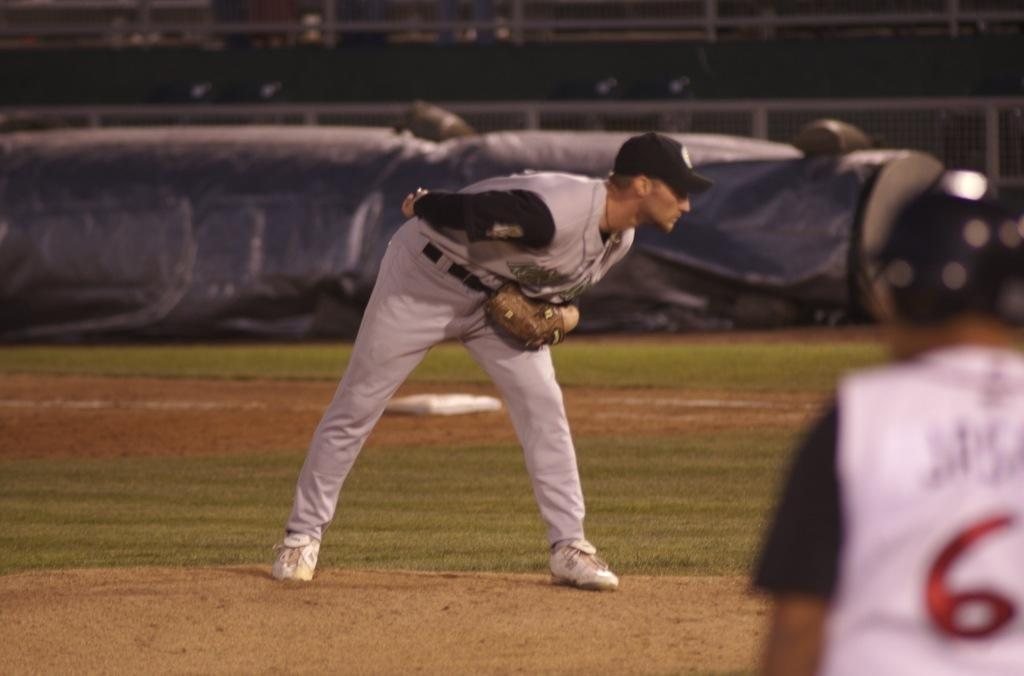<image>
Create a compact narrative representing the image presented. Player number 6 looks on as the pitcher gets ready to throw a baseball. 